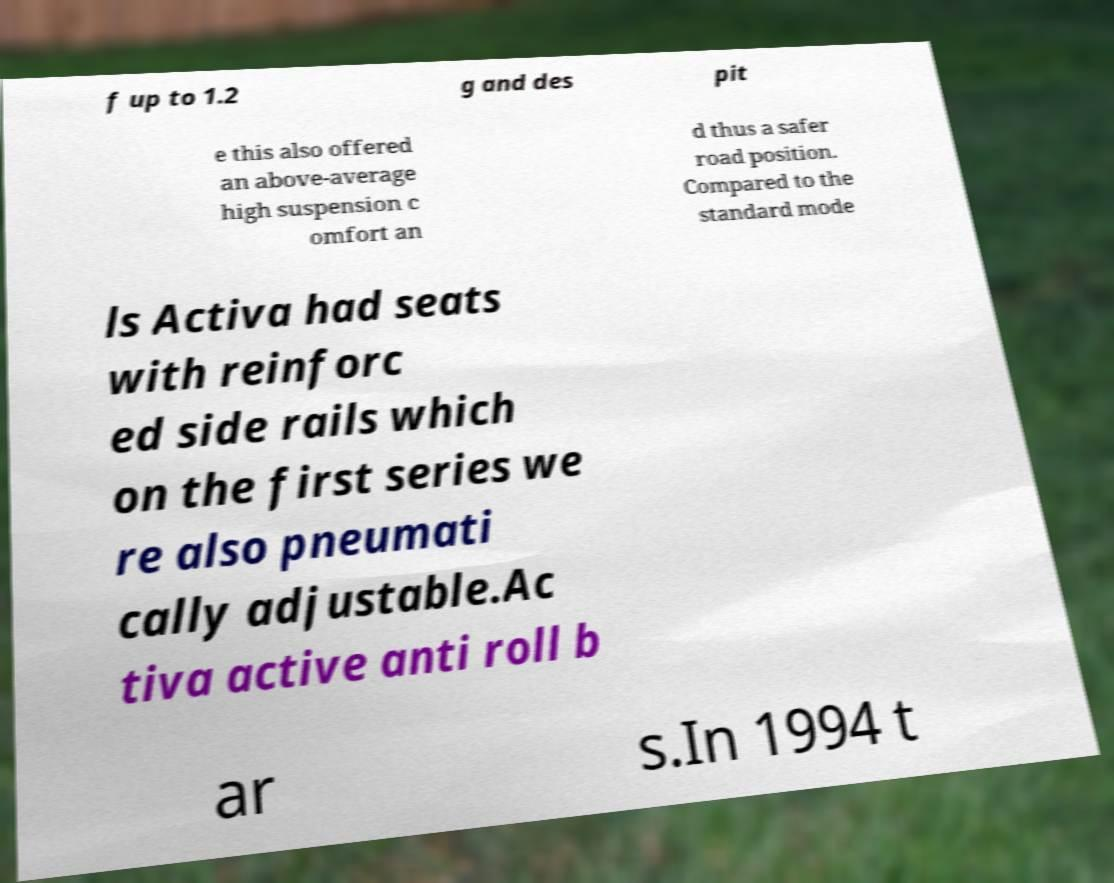Please identify and transcribe the text found in this image. f up to 1.2 g and des pit e this also offered an above-average high suspension c omfort an d thus a safer road position. Compared to the standard mode ls Activa had seats with reinforc ed side rails which on the first series we re also pneumati cally adjustable.Ac tiva active anti roll b ar s.In 1994 t 